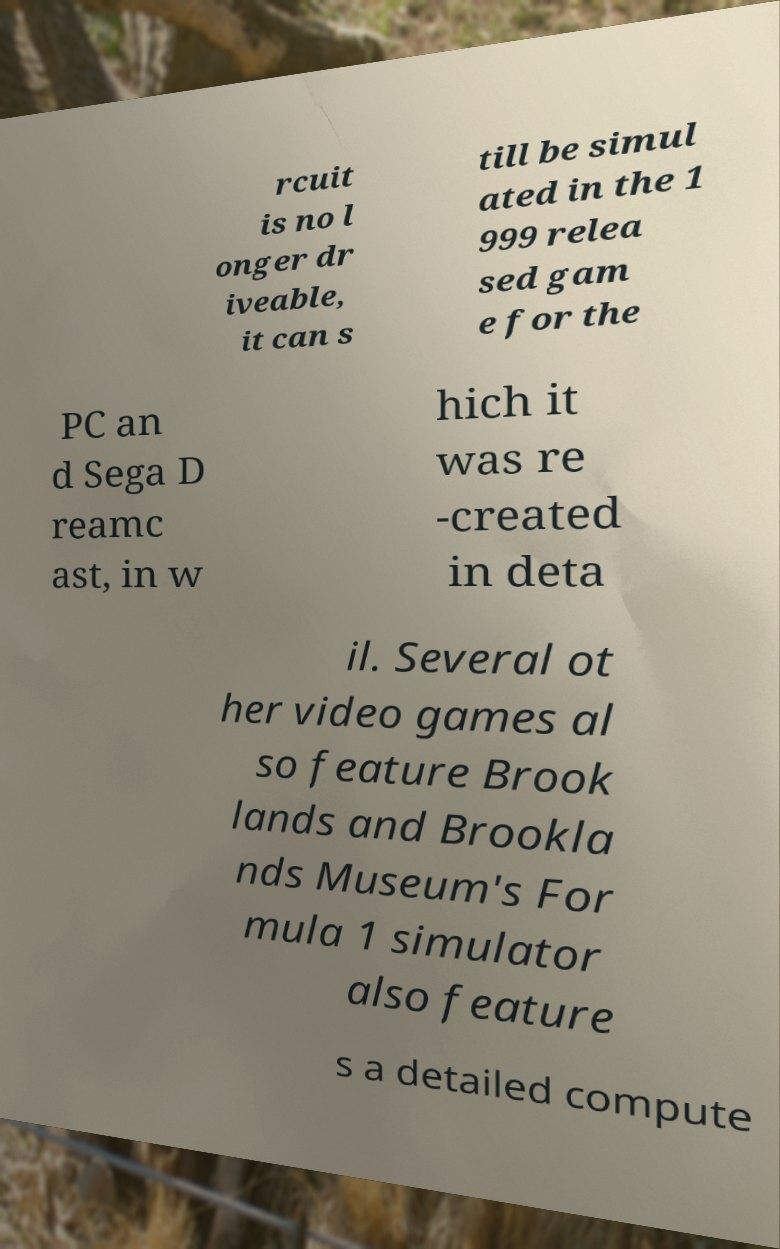Can you read and provide the text displayed in the image?This photo seems to have some interesting text. Can you extract and type it out for me? rcuit is no l onger dr iveable, it can s till be simul ated in the 1 999 relea sed gam e for the PC an d Sega D reamc ast, in w hich it was re -created in deta il. Several ot her video games al so feature Brook lands and Brookla nds Museum's For mula 1 simulator also feature s a detailed compute 